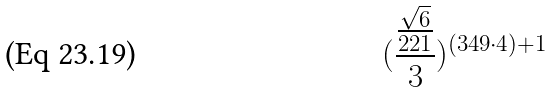<formula> <loc_0><loc_0><loc_500><loc_500>( \frac { \frac { \sqrt { 6 } } { 2 2 1 } } { 3 } ) ^ { ( 3 4 9 \cdot 4 ) + 1 }</formula> 